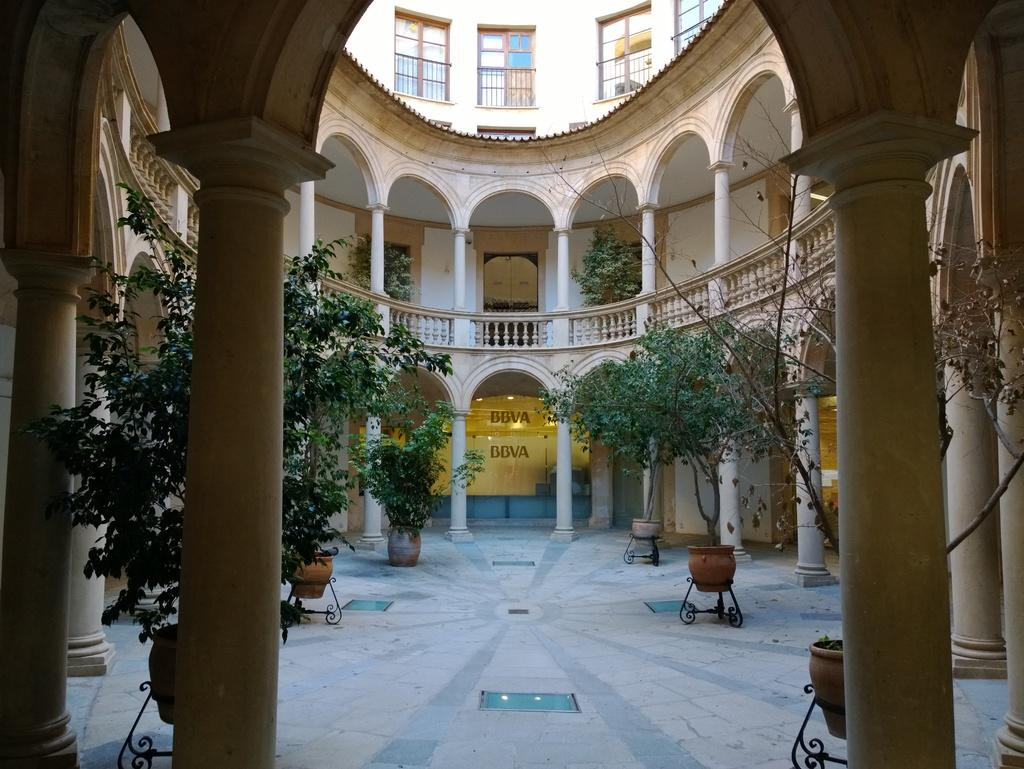What type of location is depicted in the image? The image is an inside view of a building. What architectural features can be seen in the image? There are pillars in the image. What type of vegetation is present in the image? There are plants in the image. What type of opening is visible in the image? There is a door in the image. What allows natural light to enter the building in the image? There are windows in the image. What surface is visible in the image? The image shows a floor. What type of barrier is present in the image? There is a wall in the image. How many babies are crawling on the floor in the image? There are no babies present in the image; it shows an inside view of a building with architectural and design elements. 